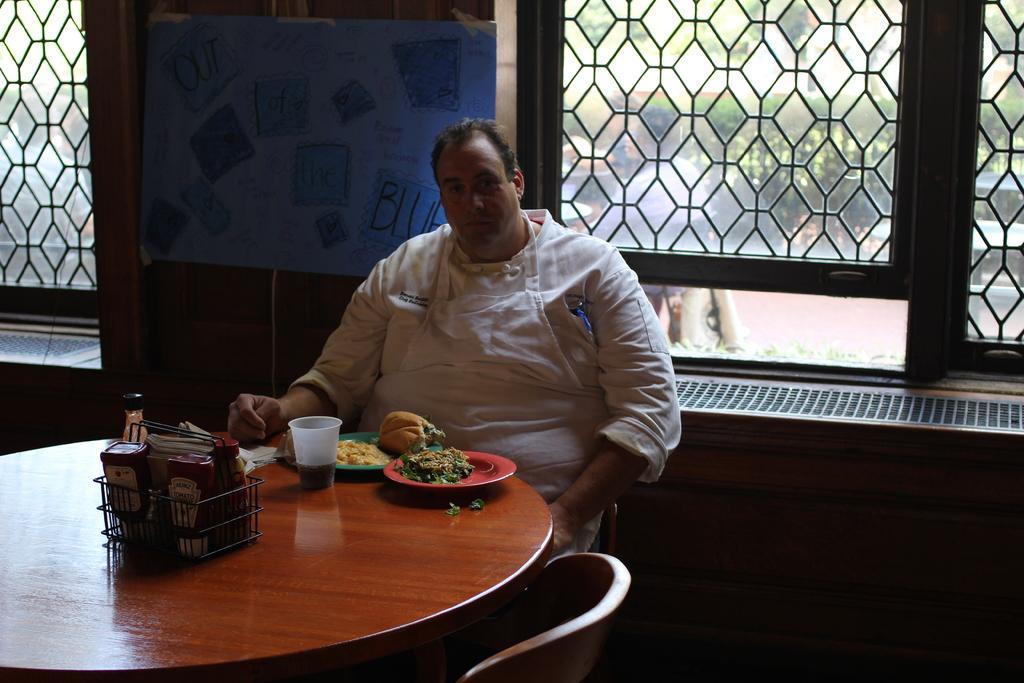Could you give a brief overview of what you see in this image? The image is inside the room. In the image there is a man sitting on chair in front of a table, on table we can see plate with some food,glass and a basket. In background we can see charts,windows which are closed,trees. 